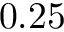Convert formula to latex. <formula><loc_0><loc_0><loc_500><loc_500>0 . 2 5</formula> 